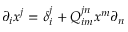Convert formula to latex. <formula><loc_0><loc_0><loc_500><loc_500>\partial _ { i } x ^ { j } = \delta _ { i } ^ { j } + Q _ { i m } ^ { j n } x ^ { m } \partial _ { n }</formula> 